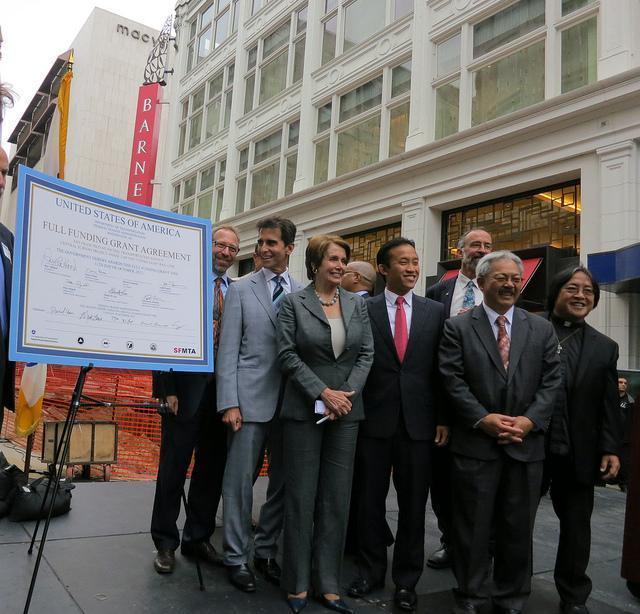How many women are posing?
Give a very brief answer. 1. How many people are in the photo?
Give a very brief answer. 8. How many men are shown?
Give a very brief answer. 7. How many backpacks are in the picture?
Give a very brief answer. 1. How many people are to the left of the motorcycles in this image?
Give a very brief answer. 0. 